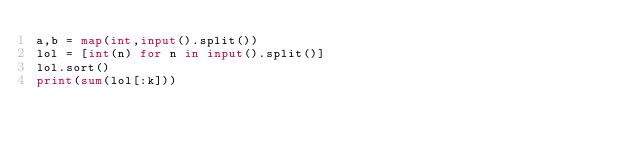Convert code to text. <code><loc_0><loc_0><loc_500><loc_500><_Python_>a,b = map(int,input().split())
lol = [int(n) for n in input().split()]
lol.sort()
print(sum(lol[:k]))</code> 